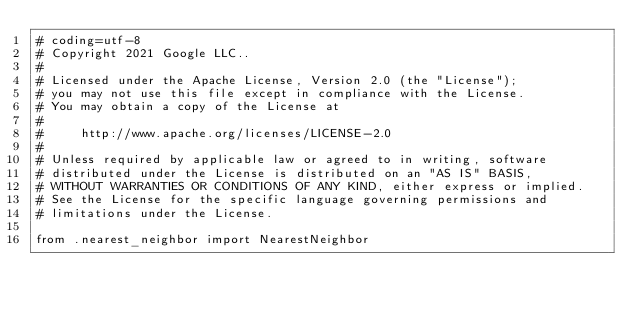<code> <loc_0><loc_0><loc_500><loc_500><_Python_># coding=utf-8
# Copyright 2021 Google LLC..
#
# Licensed under the Apache License, Version 2.0 (the "License");
# you may not use this file except in compliance with the License.
# You may obtain a copy of the License at
#
#     http://www.apache.org/licenses/LICENSE-2.0
#
# Unless required by applicable law or agreed to in writing, software
# distributed under the License is distributed on an "AS IS" BASIS,
# WITHOUT WARRANTIES OR CONDITIONS OF ANY KIND, either express or implied.
# See the License for the specific language governing permissions and
# limitations under the License.

from .nearest_neighbor import NearestNeighbor</code> 